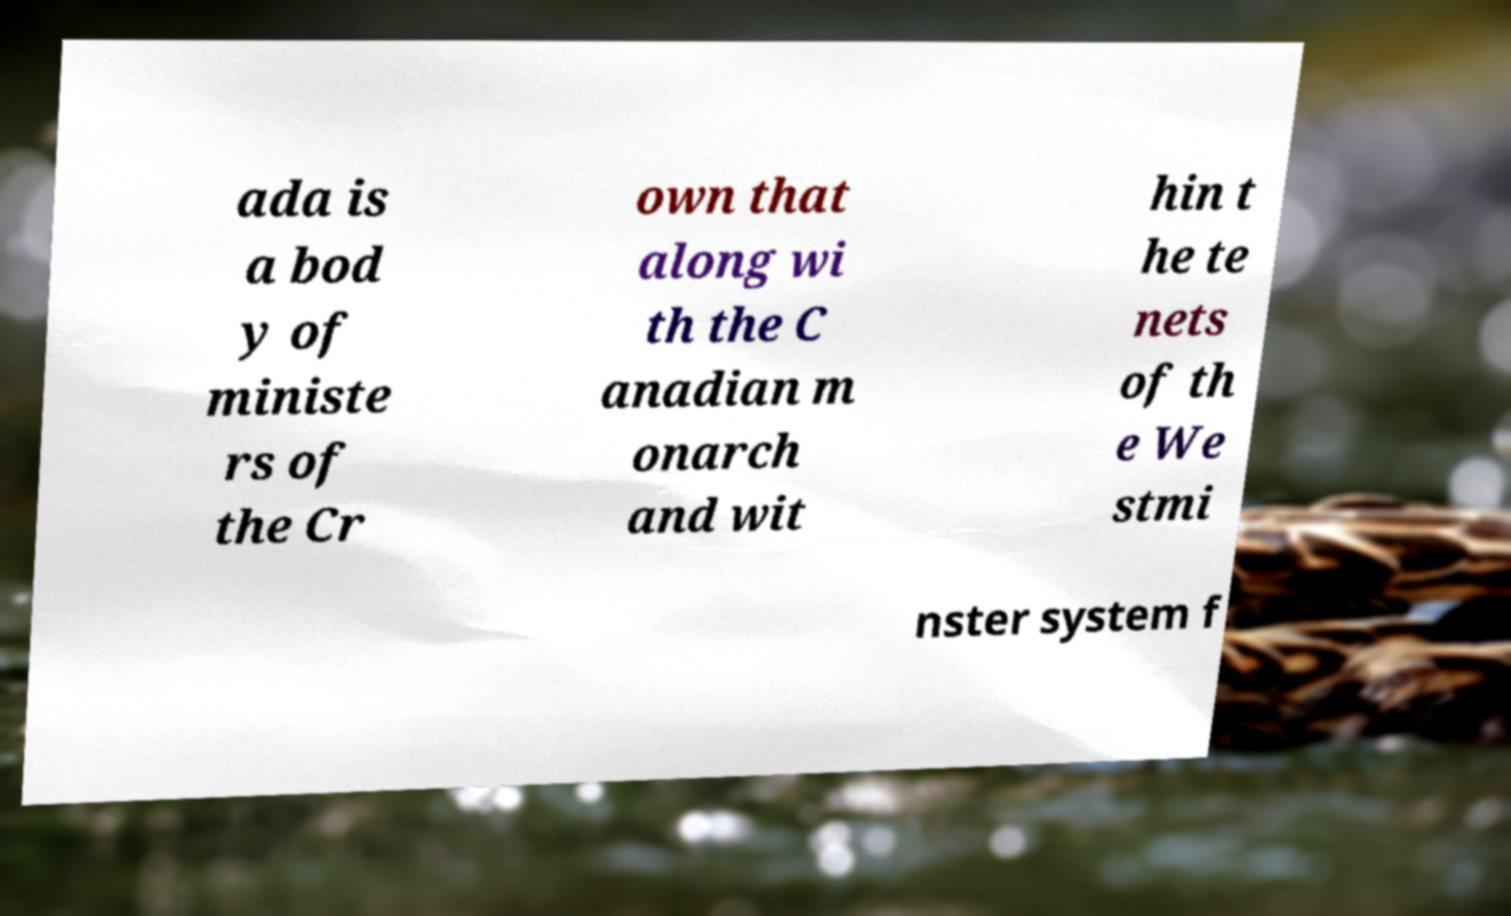Please read and relay the text visible in this image. What does it say? ada is a bod y of ministe rs of the Cr own that along wi th the C anadian m onarch and wit hin t he te nets of th e We stmi nster system f 